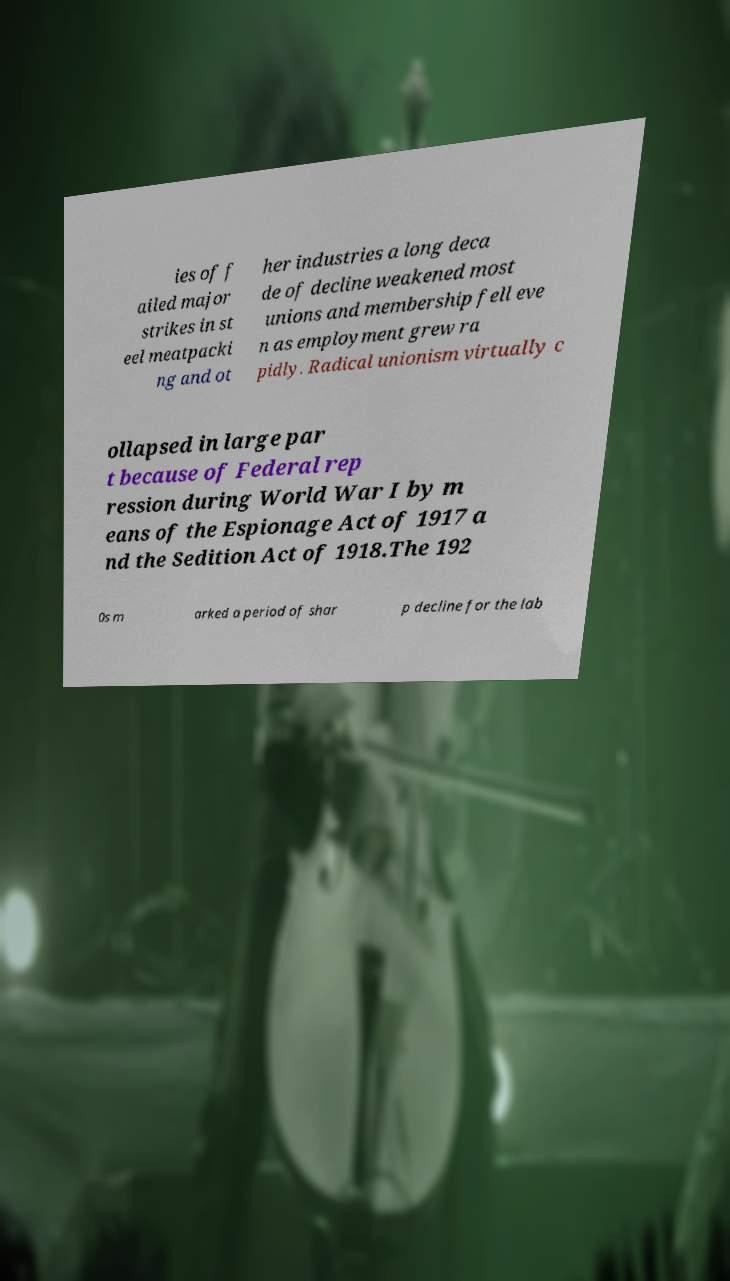Could you extract and type out the text from this image? ies of f ailed major strikes in st eel meatpacki ng and ot her industries a long deca de of decline weakened most unions and membership fell eve n as employment grew ra pidly. Radical unionism virtually c ollapsed in large par t because of Federal rep ression during World War I by m eans of the Espionage Act of 1917 a nd the Sedition Act of 1918.The 192 0s m arked a period of shar p decline for the lab 